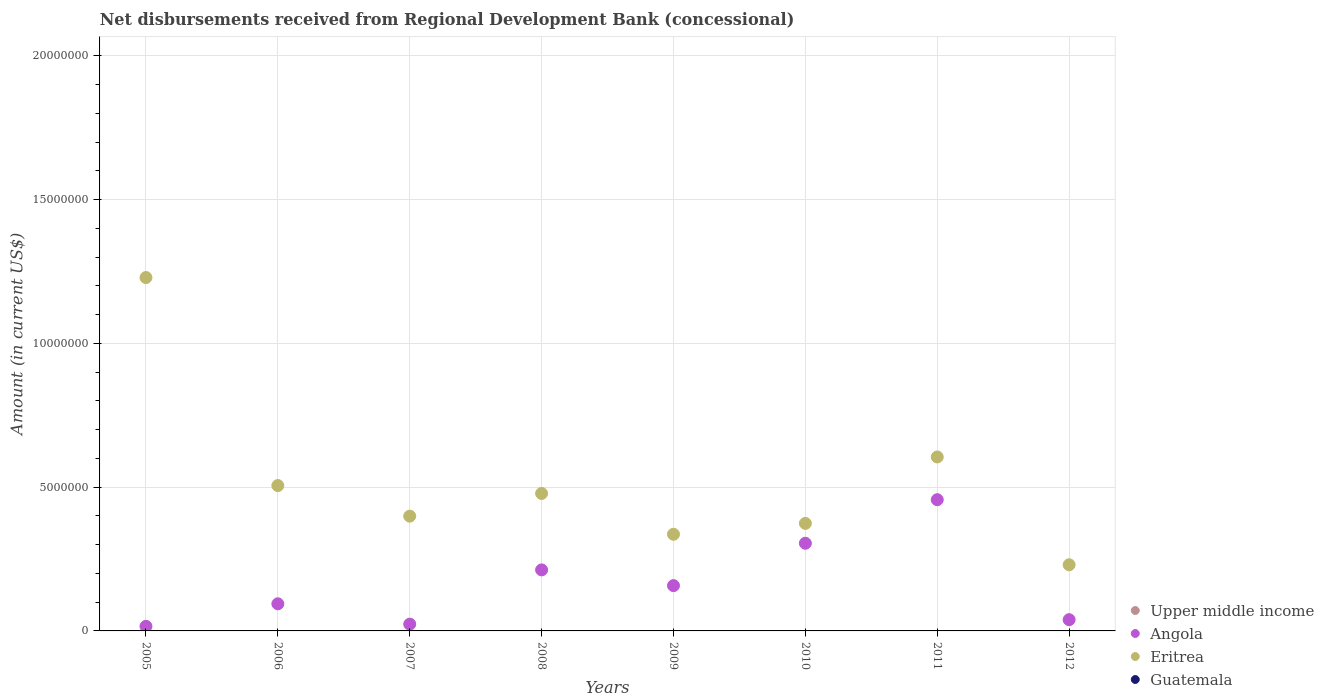How many different coloured dotlines are there?
Ensure brevity in your answer.  2. Across all years, what is the maximum amount of disbursements received from Regional Development Bank in Eritrea?
Ensure brevity in your answer.  1.23e+07. Across all years, what is the minimum amount of disbursements received from Regional Development Bank in Upper middle income?
Offer a very short reply. 0. In which year was the amount of disbursements received from Regional Development Bank in Angola maximum?
Your answer should be compact. 2011. What is the total amount of disbursements received from Regional Development Bank in Upper middle income in the graph?
Offer a terse response. 0. What is the difference between the amount of disbursements received from Regional Development Bank in Angola in 2007 and that in 2009?
Offer a terse response. -1.34e+06. What is the difference between the amount of disbursements received from Regional Development Bank in Eritrea in 2006 and the amount of disbursements received from Regional Development Bank in Angola in 2012?
Your response must be concise. 4.66e+06. What is the average amount of disbursements received from Regional Development Bank in Eritrea per year?
Give a very brief answer. 5.20e+06. In the year 2008, what is the difference between the amount of disbursements received from Regional Development Bank in Eritrea and amount of disbursements received from Regional Development Bank in Angola?
Make the answer very short. 2.66e+06. What is the ratio of the amount of disbursements received from Regional Development Bank in Angola in 2009 to that in 2011?
Your answer should be compact. 0.35. Is the difference between the amount of disbursements received from Regional Development Bank in Eritrea in 2006 and 2008 greater than the difference between the amount of disbursements received from Regional Development Bank in Angola in 2006 and 2008?
Offer a terse response. Yes. What is the difference between the highest and the second highest amount of disbursements received from Regional Development Bank in Angola?
Ensure brevity in your answer.  1.52e+06. What is the difference between the highest and the lowest amount of disbursements received from Regional Development Bank in Angola?
Offer a very short reply. 4.40e+06. Is it the case that in every year, the sum of the amount of disbursements received from Regional Development Bank in Upper middle income and amount of disbursements received from Regional Development Bank in Angola  is greater than the sum of amount of disbursements received from Regional Development Bank in Guatemala and amount of disbursements received from Regional Development Bank in Eritrea?
Make the answer very short. No. Is the amount of disbursements received from Regional Development Bank in Angola strictly less than the amount of disbursements received from Regional Development Bank in Eritrea over the years?
Keep it short and to the point. Yes. What is the difference between two consecutive major ticks on the Y-axis?
Make the answer very short. 5.00e+06. Does the graph contain any zero values?
Your answer should be very brief. Yes. Does the graph contain grids?
Give a very brief answer. Yes. Where does the legend appear in the graph?
Offer a terse response. Bottom right. How many legend labels are there?
Ensure brevity in your answer.  4. What is the title of the graph?
Your answer should be compact. Net disbursements received from Regional Development Bank (concessional). What is the label or title of the X-axis?
Keep it short and to the point. Years. What is the label or title of the Y-axis?
Make the answer very short. Amount (in current US$). What is the Amount (in current US$) of Angola in 2005?
Provide a short and direct response. 1.59e+05. What is the Amount (in current US$) of Eritrea in 2005?
Your answer should be compact. 1.23e+07. What is the Amount (in current US$) of Guatemala in 2005?
Ensure brevity in your answer.  0. What is the Amount (in current US$) in Angola in 2006?
Your answer should be compact. 9.43e+05. What is the Amount (in current US$) of Eritrea in 2006?
Ensure brevity in your answer.  5.05e+06. What is the Amount (in current US$) in Guatemala in 2006?
Offer a very short reply. 0. What is the Amount (in current US$) of Upper middle income in 2007?
Ensure brevity in your answer.  0. What is the Amount (in current US$) of Angola in 2007?
Your answer should be compact. 2.36e+05. What is the Amount (in current US$) of Eritrea in 2007?
Offer a terse response. 3.99e+06. What is the Amount (in current US$) in Angola in 2008?
Your response must be concise. 2.12e+06. What is the Amount (in current US$) of Eritrea in 2008?
Give a very brief answer. 4.78e+06. What is the Amount (in current US$) in Guatemala in 2008?
Your response must be concise. 0. What is the Amount (in current US$) of Upper middle income in 2009?
Keep it short and to the point. 0. What is the Amount (in current US$) of Angola in 2009?
Offer a terse response. 1.58e+06. What is the Amount (in current US$) of Eritrea in 2009?
Give a very brief answer. 3.36e+06. What is the Amount (in current US$) of Upper middle income in 2010?
Your answer should be very brief. 0. What is the Amount (in current US$) in Angola in 2010?
Your answer should be very brief. 3.05e+06. What is the Amount (in current US$) in Eritrea in 2010?
Give a very brief answer. 3.74e+06. What is the Amount (in current US$) in Upper middle income in 2011?
Your answer should be compact. 0. What is the Amount (in current US$) of Angola in 2011?
Ensure brevity in your answer.  4.56e+06. What is the Amount (in current US$) in Eritrea in 2011?
Provide a short and direct response. 6.05e+06. What is the Amount (in current US$) of Guatemala in 2011?
Provide a short and direct response. 0. What is the Amount (in current US$) in Angola in 2012?
Offer a terse response. 3.91e+05. What is the Amount (in current US$) in Eritrea in 2012?
Keep it short and to the point. 2.30e+06. Across all years, what is the maximum Amount (in current US$) of Angola?
Offer a terse response. 4.56e+06. Across all years, what is the maximum Amount (in current US$) in Eritrea?
Offer a very short reply. 1.23e+07. Across all years, what is the minimum Amount (in current US$) in Angola?
Ensure brevity in your answer.  1.59e+05. Across all years, what is the minimum Amount (in current US$) in Eritrea?
Your answer should be very brief. 2.30e+06. What is the total Amount (in current US$) of Upper middle income in the graph?
Provide a short and direct response. 0. What is the total Amount (in current US$) in Angola in the graph?
Keep it short and to the point. 1.30e+07. What is the total Amount (in current US$) in Eritrea in the graph?
Your response must be concise. 4.16e+07. What is the total Amount (in current US$) of Guatemala in the graph?
Your response must be concise. 0. What is the difference between the Amount (in current US$) in Angola in 2005 and that in 2006?
Provide a succinct answer. -7.84e+05. What is the difference between the Amount (in current US$) of Eritrea in 2005 and that in 2006?
Ensure brevity in your answer.  7.23e+06. What is the difference between the Amount (in current US$) of Angola in 2005 and that in 2007?
Your response must be concise. -7.70e+04. What is the difference between the Amount (in current US$) in Eritrea in 2005 and that in 2007?
Make the answer very short. 8.30e+06. What is the difference between the Amount (in current US$) in Angola in 2005 and that in 2008?
Your response must be concise. -1.96e+06. What is the difference between the Amount (in current US$) in Eritrea in 2005 and that in 2008?
Offer a terse response. 7.51e+06. What is the difference between the Amount (in current US$) in Angola in 2005 and that in 2009?
Your answer should be compact. -1.42e+06. What is the difference between the Amount (in current US$) of Eritrea in 2005 and that in 2009?
Give a very brief answer. 8.93e+06. What is the difference between the Amount (in current US$) of Angola in 2005 and that in 2010?
Provide a succinct answer. -2.89e+06. What is the difference between the Amount (in current US$) in Eritrea in 2005 and that in 2010?
Make the answer very short. 8.55e+06. What is the difference between the Amount (in current US$) in Angola in 2005 and that in 2011?
Your answer should be very brief. -4.40e+06. What is the difference between the Amount (in current US$) in Eritrea in 2005 and that in 2011?
Keep it short and to the point. 6.24e+06. What is the difference between the Amount (in current US$) in Angola in 2005 and that in 2012?
Keep it short and to the point. -2.32e+05. What is the difference between the Amount (in current US$) of Eritrea in 2005 and that in 2012?
Your response must be concise. 9.99e+06. What is the difference between the Amount (in current US$) of Angola in 2006 and that in 2007?
Your response must be concise. 7.07e+05. What is the difference between the Amount (in current US$) of Eritrea in 2006 and that in 2007?
Make the answer very short. 1.06e+06. What is the difference between the Amount (in current US$) of Angola in 2006 and that in 2008?
Make the answer very short. -1.18e+06. What is the difference between the Amount (in current US$) of Eritrea in 2006 and that in 2008?
Your answer should be very brief. 2.74e+05. What is the difference between the Amount (in current US$) in Angola in 2006 and that in 2009?
Your answer should be very brief. -6.32e+05. What is the difference between the Amount (in current US$) of Eritrea in 2006 and that in 2009?
Your response must be concise. 1.69e+06. What is the difference between the Amount (in current US$) of Angola in 2006 and that in 2010?
Give a very brief answer. -2.10e+06. What is the difference between the Amount (in current US$) of Eritrea in 2006 and that in 2010?
Your answer should be very brief. 1.32e+06. What is the difference between the Amount (in current US$) in Angola in 2006 and that in 2011?
Offer a very short reply. -3.62e+06. What is the difference between the Amount (in current US$) of Eritrea in 2006 and that in 2011?
Keep it short and to the point. -9.95e+05. What is the difference between the Amount (in current US$) in Angola in 2006 and that in 2012?
Provide a succinct answer. 5.52e+05. What is the difference between the Amount (in current US$) of Eritrea in 2006 and that in 2012?
Provide a succinct answer. 2.75e+06. What is the difference between the Amount (in current US$) of Angola in 2007 and that in 2008?
Keep it short and to the point. -1.89e+06. What is the difference between the Amount (in current US$) of Eritrea in 2007 and that in 2008?
Offer a very short reply. -7.89e+05. What is the difference between the Amount (in current US$) of Angola in 2007 and that in 2009?
Offer a terse response. -1.34e+06. What is the difference between the Amount (in current US$) in Eritrea in 2007 and that in 2009?
Provide a succinct answer. 6.30e+05. What is the difference between the Amount (in current US$) in Angola in 2007 and that in 2010?
Offer a terse response. -2.81e+06. What is the difference between the Amount (in current US$) of Eritrea in 2007 and that in 2010?
Offer a very short reply. 2.52e+05. What is the difference between the Amount (in current US$) in Angola in 2007 and that in 2011?
Provide a succinct answer. -4.33e+06. What is the difference between the Amount (in current US$) in Eritrea in 2007 and that in 2011?
Your response must be concise. -2.06e+06. What is the difference between the Amount (in current US$) of Angola in 2007 and that in 2012?
Offer a terse response. -1.55e+05. What is the difference between the Amount (in current US$) of Eritrea in 2007 and that in 2012?
Make the answer very short. 1.69e+06. What is the difference between the Amount (in current US$) in Angola in 2008 and that in 2009?
Offer a terse response. 5.47e+05. What is the difference between the Amount (in current US$) in Eritrea in 2008 and that in 2009?
Make the answer very short. 1.42e+06. What is the difference between the Amount (in current US$) of Angola in 2008 and that in 2010?
Ensure brevity in your answer.  -9.26e+05. What is the difference between the Amount (in current US$) of Eritrea in 2008 and that in 2010?
Your response must be concise. 1.04e+06. What is the difference between the Amount (in current US$) in Angola in 2008 and that in 2011?
Your answer should be very brief. -2.44e+06. What is the difference between the Amount (in current US$) in Eritrea in 2008 and that in 2011?
Offer a terse response. -1.27e+06. What is the difference between the Amount (in current US$) in Angola in 2008 and that in 2012?
Make the answer very short. 1.73e+06. What is the difference between the Amount (in current US$) in Eritrea in 2008 and that in 2012?
Your response must be concise. 2.48e+06. What is the difference between the Amount (in current US$) in Angola in 2009 and that in 2010?
Make the answer very short. -1.47e+06. What is the difference between the Amount (in current US$) in Eritrea in 2009 and that in 2010?
Offer a terse response. -3.78e+05. What is the difference between the Amount (in current US$) in Angola in 2009 and that in 2011?
Your answer should be very brief. -2.99e+06. What is the difference between the Amount (in current US$) of Eritrea in 2009 and that in 2011?
Offer a terse response. -2.69e+06. What is the difference between the Amount (in current US$) of Angola in 2009 and that in 2012?
Keep it short and to the point. 1.18e+06. What is the difference between the Amount (in current US$) in Eritrea in 2009 and that in 2012?
Ensure brevity in your answer.  1.06e+06. What is the difference between the Amount (in current US$) in Angola in 2010 and that in 2011?
Offer a very short reply. -1.52e+06. What is the difference between the Amount (in current US$) of Eritrea in 2010 and that in 2011?
Your answer should be compact. -2.31e+06. What is the difference between the Amount (in current US$) in Angola in 2010 and that in 2012?
Provide a short and direct response. 2.66e+06. What is the difference between the Amount (in current US$) of Eritrea in 2010 and that in 2012?
Make the answer very short. 1.44e+06. What is the difference between the Amount (in current US$) of Angola in 2011 and that in 2012?
Your answer should be compact. 4.17e+06. What is the difference between the Amount (in current US$) of Eritrea in 2011 and that in 2012?
Make the answer very short. 3.75e+06. What is the difference between the Amount (in current US$) in Angola in 2005 and the Amount (in current US$) in Eritrea in 2006?
Provide a short and direct response. -4.90e+06. What is the difference between the Amount (in current US$) of Angola in 2005 and the Amount (in current US$) of Eritrea in 2007?
Keep it short and to the point. -3.83e+06. What is the difference between the Amount (in current US$) of Angola in 2005 and the Amount (in current US$) of Eritrea in 2008?
Offer a terse response. -4.62e+06. What is the difference between the Amount (in current US$) in Angola in 2005 and the Amount (in current US$) in Eritrea in 2009?
Make the answer very short. -3.20e+06. What is the difference between the Amount (in current US$) in Angola in 2005 and the Amount (in current US$) in Eritrea in 2010?
Offer a very short reply. -3.58e+06. What is the difference between the Amount (in current US$) in Angola in 2005 and the Amount (in current US$) in Eritrea in 2011?
Ensure brevity in your answer.  -5.89e+06. What is the difference between the Amount (in current US$) of Angola in 2005 and the Amount (in current US$) of Eritrea in 2012?
Your answer should be very brief. -2.14e+06. What is the difference between the Amount (in current US$) in Angola in 2006 and the Amount (in current US$) in Eritrea in 2007?
Offer a very short reply. -3.05e+06. What is the difference between the Amount (in current US$) in Angola in 2006 and the Amount (in current US$) in Eritrea in 2008?
Give a very brief answer. -3.84e+06. What is the difference between the Amount (in current US$) in Angola in 2006 and the Amount (in current US$) in Eritrea in 2009?
Offer a very short reply. -2.42e+06. What is the difference between the Amount (in current US$) in Angola in 2006 and the Amount (in current US$) in Eritrea in 2010?
Give a very brief answer. -2.80e+06. What is the difference between the Amount (in current US$) of Angola in 2006 and the Amount (in current US$) of Eritrea in 2011?
Keep it short and to the point. -5.11e+06. What is the difference between the Amount (in current US$) in Angola in 2006 and the Amount (in current US$) in Eritrea in 2012?
Your answer should be compact. -1.36e+06. What is the difference between the Amount (in current US$) in Angola in 2007 and the Amount (in current US$) in Eritrea in 2008?
Your answer should be very brief. -4.54e+06. What is the difference between the Amount (in current US$) of Angola in 2007 and the Amount (in current US$) of Eritrea in 2009?
Make the answer very short. -3.12e+06. What is the difference between the Amount (in current US$) in Angola in 2007 and the Amount (in current US$) in Eritrea in 2010?
Provide a short and direct response. -3.50e+06. What is the difference between the Amount (in current US$) of Angola in 2007 and the Amount (in current US$) of Eritrea in 2011?
Make the answer very short. -5.81e+06. What is the difference between the Amount (in current US$) in Angola in 2007 and the Amount (in current US$) in Eritrea in 2012?
Ensure brevity in your answer.  -2.06e+06. What is the difference between the Amount (in current US$) in Angola in 2008 and the Amount (in current US$) in Eritrea in 2009?
Offer a terse response. -1.24e+06. What is the difference between the Amount (in current US$) of Angola in 2008 and the Amount (in current US$) of Eritrea in 2010?
Ensure brevity in your answer.  -1.62e+06. What is the difference between the Amount (in current US$) of Angola in 2008 and the Amount (in current US$) of Eritrea in 2011?
Your answer should be very brief. -3.93e+06. What is the difference between the Amount (in current US$) of Angola in 2008 and the Amount (in current US$) of Eritrea in 2012?
Provide a succinct answer. -1.78e+05. What is the difference between the Amount (in current US$) in Angola in 2009 and the Amount (in current US$) in Eritrea in 2010?
Give a very brief answer. -2.16e+06. What is the difference between the Amount (in current US$) in Angola in 2009 and the Amount (in current US$) in Eritrea in 2011?
Offer a very short reply. -4.47e+06. What is the difference between the Amount (in current US$) in Angola in 2009 and the Amount (in current US$) in Eritrea in 2012?
Give a very brief answer. -7.25e+05. What is the difference between the Amount (in current US$) in Angola in 2010 and the Amount (in current US$) in Eritrea in 2011?
Provide a succinct answer. -3.00e+06. What is the difference between the Amount (in current US$) in Angola in 2010 and the Amount (in current US$) in Eritrea in 2012?
Keep it short and to the point. 7.48e+05. What is the difference between the Amount (in current US$) of Angola in 2011 and the Amount (in current US$) of Eritrea in 2012?
Your response must be concise. 2.26e+06. What is the average Amount (in current US$) in Upper middle income per year?
Provide a succinct answer. 0. What is the average Amount (in current US$) in Angola per year?
Your answer should be very brief. 1.63e+06. What is the average Amount (in current US$) in Eritrea per year?
Give a very brief answer. 5.20e+06. What is the average Amount (in current US$) in Guatemala per year?
Your response must be concise. 0. In the year 2005, what is the difference between the Amount (in current US$) in Angola and Amount (in current US$) in Eritrea?
Provide a succinct answer. -1.21e+07. In the year 2006, what is the difference between the Amount (in current US$) of Angola and Amount (in current US$) of Eritrea?
Your response must be concise. -4.11e+06. In the year 2007, what is the difference between the Amount (in current US$) in Angola and Amount (in current US$) in Eritrea?
Offer a terse response. -3.76e+06. In the year 2008, what is the difference between the Amount (in current US$) in Angola and Amount (in current US$) in Eritrea?
Your answer should be compact. -2.66e+06. In the year 2009, what is the difference between the Amount (in current US$) of Angola and Amount (in current US$) of Eritrea?
Offer a very short reply. -1.79e+06. In the year 2010, what is the difference between the Amount (in current US$) in Angola and Amount (in current US$) in Eritrea?
Make the answer very short. -6.91e+05. In the year 2011, what is the difference between the Amount (in current US$) in Angola and Amount (in current US$) in Eritrea?
Offer a terse response. -1.49e+06. In the year 2012, what is the difference between the Amount (in current US$) in Angola and Amount (in current US$) in Eritrea?
Your answer should be very brief. -1.91e+06. What is the ratio of the Amount (in current US$) in Angola in 2005 to that in 2006?
Your answer should be very brief. 0.17. What is the ratio of the Amount (in current US$) in Eritrea in 2005 to that in 2006?
Offer a terse response. 2.43. What is the ratio of the Amount (in current US$) in Angola in 2005 to that in 2007?
Your answer should be very brief. 0.67. What is the ratio of the Amount (in current US$) in Eritrea in 2005 to that in 2007?
Offer a very short reply. 3.08. What is the ratio of the Amount (in current US$) of Angola in 2005 to that in 2008?
Your answer should be very brief. 0.07. What is the ratio of the Amount (in current US$) in Eritrea in 2005 to that in 2008?
Your response must be concise. 2.57. What is the ratio of the Amount (in current US$) in Angola in 2005 to that in 2009?
Keep it short and to the point. 0.1. What is the ratio of the Amount (in current US$) in Eritrea in 2005 to that in 2009?
Your answer should be very brief. 3.66. What is the ratio of the Amount (in current US$) in Angola in 2005 to that in 2010?
Offer a terse response. 0.05. What is the ratio of the Amount (in current US$) of Eritrea in 2005 to that in 2010?
Offer a very short reply. 3.29. What is the ratio of the Amount (in current US$) of Angola in 2005 to that in 2011?
Your answer should be very brief. 0.03. What is the ratio of the Amount (in current US$) in Eritrea in 2005 to that in 2011?
Provide a short and direct response. 2.03. What is the ratio of the Amount (in current US$) in Angola in 2005 to that in 2012?
Provide a short and direct response. 0.41. What is the ratio of the Amount (in current US$) in Eritrea in 2005 to that in 2012?
Provide a short and direct response. 5.34. What is the ratio of the Amount (in current US$) of Angola in 2006 to that in 2007?
Your answer should be very brief. 4. What is the ratio of the Amount (in current US$) of Eritrea in 2006 to that in 2007?
Offer a very short reply. 1.27. What is the ratio of the Amount (in current US$) of Angola in 2006 to that in 2008?
Provide a short and direct response. 0.44. What is the ratio of the Amount (in current US$) of Eritrea in 2006 to that in 2008?
Make the answer very short. 1.06. What is the ratio of the Amount (in current US$) in Angola in 2006 to that in 2009?
Provide a short and direct response. 0.6. What is the ratio of the Amount (in current US$) in Eritrea in 2006 to that in 2009?
Make the answer very short. 1.5. What is the ratio of the Amount (in current US$) of Angola in 2006 to that in 2010?
Provide a short and direct response. 0.31. What is the ratio of the Amount (in current US$) of Eritrea in 2006 to that in 2010?
Your answer should be very brief. 1.35. What is the ratio of the Amount (in current US$) of Angola in 2006 to that in 2011?
Your answer should be very brief. 0.21. What is the ratio of the Amount (in current US$) in Eritrea in 2006 to that in 2011?
Your response must be concise. 0.84. What is the ratio of the Amount (in current US$) in Angola in 2006 to that in 2012?
Your answer should be very brief. 2.41. What is the ratio of the Amount (in current US$) of Eritrea in 2006 to that in 2012?
Your response must be concise. 2.2. What is the ratio of the Amount (in current US$) of Angola in 2007 to that in 2008?
Offer a very short reply. 0.11. What is the ratio of the Amount (in current US$) of Eritrea in 2007 to that in 2008?
Provide a short and direct response. 0.83. What is the ratio of the Amount (in current US$) of Angola in 2007 to that in 2009?
Your response must be concise. 0.15. What is the ratio of the Amount (in current US$) of Eritrea in 2007 to that in 2009?
Offer a very short reply. 1.19. What is the ratio of the Amount (in current US$) of Angola in 2007 to that in 2010?
Provide a succinct answer. 0.08. What is the ratio of the Amount (in current US$) in Eritrea in 2007 to that in 2010?
Provide a succinct answer. 1.07. What is the ratio of the Amount (in current US$) of Angola in 2007 to that in 2011?
Your answer should be very brief. 0.05. What is the ratio of the Amount (in current US$) in Eritrea in 2007 to that in 2011?
Your answer should be compact. 0.66. What is the ratio of the Amount (in current US$) in Angola in 2007 to that in 2012?
Make the answer very short. 0.6. What is the ratio of the Amount (in current US$) of Eritrea in 2007 to that in 2012?
Give a very brief answer. 1.74. What is the ratio of the Amount (in current US$) in Angola in 2008 to that in 2009?
Ensure brevity in your answer.  1.35. What is the ratio of the Amount (in current US$) in Eritrea in 2008 to that in 2009?
Keep it short and to the point. 1.42. What is the ratio of the Amount (in current US$) of Angola in 2008 to that in 2010?
Give a very brief answer. 0.7. What is the ratio of the Amount (in current US$) of Eritrea in 2008 to that in 2010?
Keep it short and to the point. 1.28. What is the ratio of the Amount (in current US$) in Angola in 2008 to that in 2011?
Offer a terse response. 0.47. What is the ratio of the Amount (in current US$) in Eritrea in 2008 to that in 2011?
Make the answer very short. 0.79. What is the ratio of the Amount (in current US$) of Angola in 2008 to that in 2012?
Offer a terse response. 5.43. What is the ratio of the Amount (in current US$) in Eritrea in 2008 to that in 2012?
Offer a terse response. 2.08. What is the ratio of the Amount (in current US$) in Angola in 2009 to that in 2010?
Your answer should be compact. 0.52. What is the ratio of the Amount (in current US$) in Eritrea in 2009 to that in 2010?
Give a very brief answer. 0.9. What is the ratio of the Amount (in current US$) of Angola in 2009 to that in 2011?
Make the answer very short. 0.35. What is the ratio of the Amount (in current US$) in Eritrea in 2009 to that in 2011?
Offer a terse response. 0.56. What is the ratio of the Amount (in current US$) in Angola in 2009 to that in 2012?
Provide a succinct answer. 4.03. What is the ratio of the Amount (in current US$) of Eritrea in 2009 to that in 2012?
Make the answer very short. 1.46. What is the ratio of the Amount (in current US$) in Angola in 2010 to that in 2011?
Offer a terse response. 0.67. What is the ratio of the Amount (in current US$) in Eritrea in 2010 to that in 2011?
Your answer should be compact. 0.62. What is the ratio of the Amount (in current US$) of Angola in 2010 to that in 2012?
Offer a very short reply. 7.8. What is the ratio of the Amount (in current US$) in Eritrea in 2010 to that in 2012?
Offer a very short reply. 1.63. What is the ratio of the Amount (in current US$) of Angola in 2011 to that in 2012?
Your answer should be compact. 11.67. What is the ratio of the Amount (in current US$) in Eritrea in 2011 to that in 2012?
Ensure brevity in your answer.  2.63. What is the difference between the highest and the second highest Amount (in current US$) in Angola?
Your answer should be very brief. 1.52e+06. What is the difference between the highest and the second highest Amount (in current US$) in Eritrea?
Offer a terse response. 6.24e+06. What is the difference between the highest and the lowest Amount (in current US$) in Angola?
Your answer should be very brief. 4.40e+06. What is the difference between the highest and the lowest Amount (in current US$) in Eritrea?
Make the answer very short. 9.99e+06. 